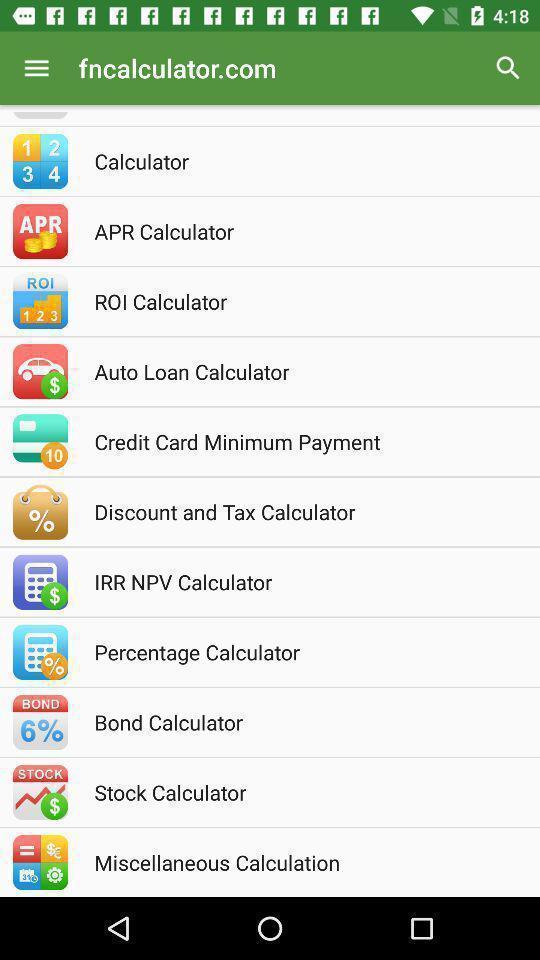What details can you identify in this image? Screen displaying list of applications. 